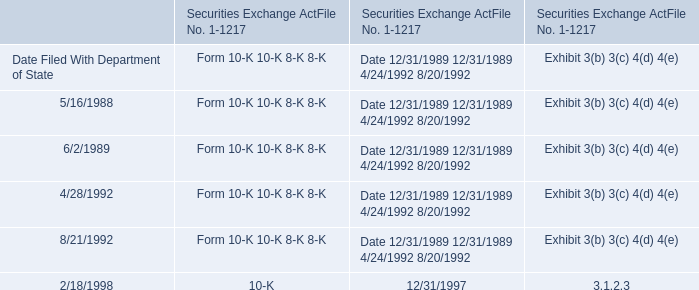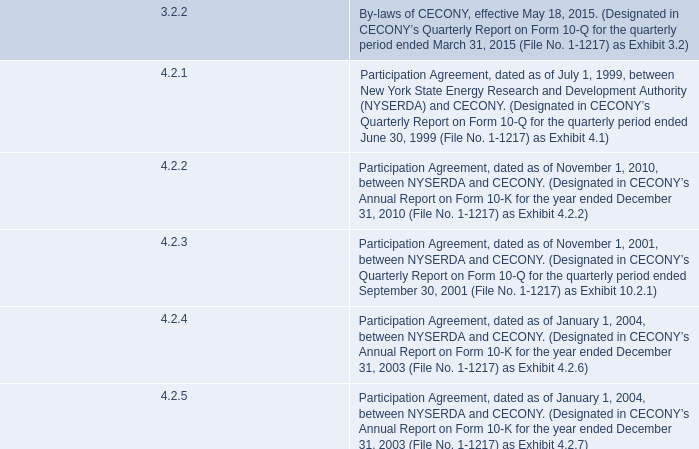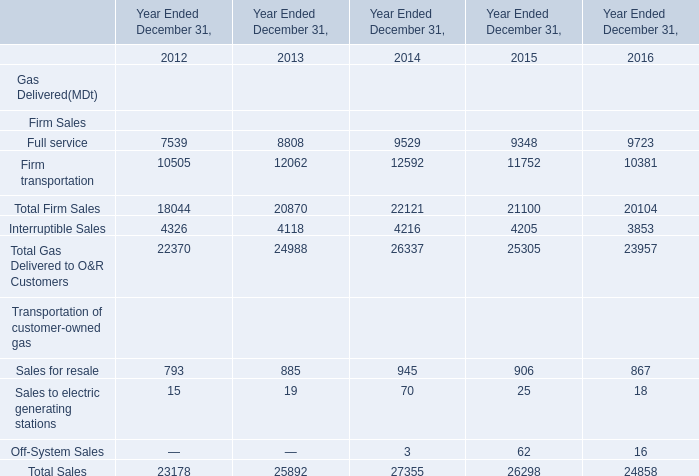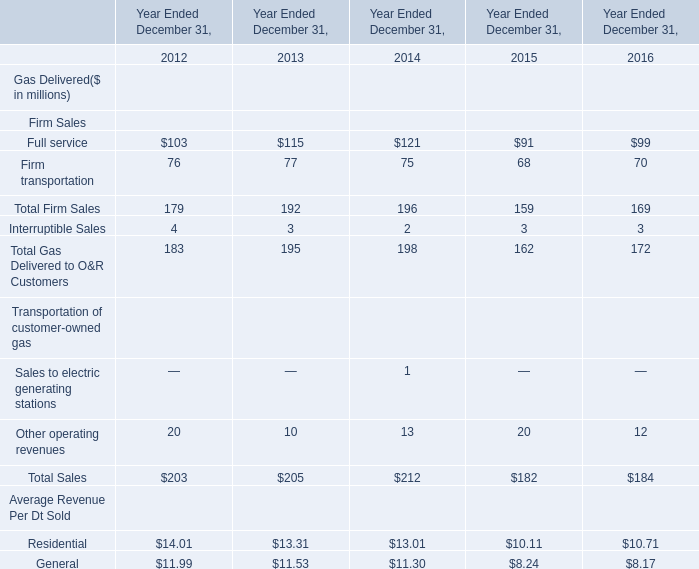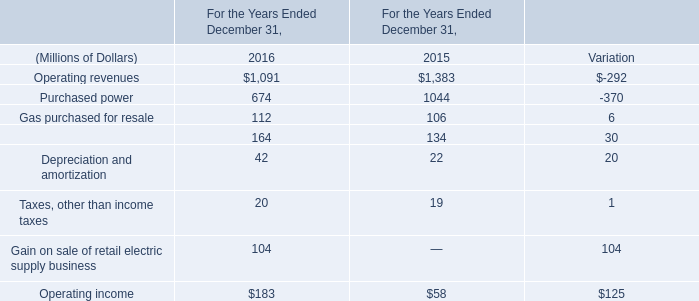What will Sales for resale be like in 2017 if it develops with the same increasing rate as current? 
Computations: ((1 + ((867 - 906) / 906)) * 867)
Answer: 829.67881. 